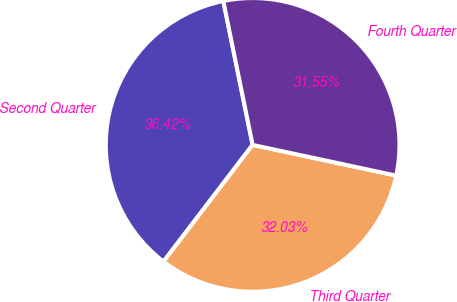Convert chart. <chart><loc_0><loc_0><loc_500><loc_500><pie_chart><fcel>Second Quarter<fcel>Third Quarter<fcel>Fourth Quarter<nl><fcel>36.42%<fcel>32.03%<fcel>31.55%<nl></chart> 